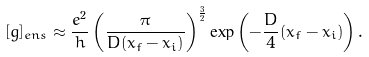<formula> <loc_0><loc_0><loc_500><loc_500>[ g ] _ { e n s } \approx \frac { e ^ { 2 } } { h } \left ( \frac { \pi } { D ( x _ { f } - x _ { i } ) } \right ) ^ { \frac { 3 } { 2 } } \exp \left ( - \frac { D } { 4 } ( x _ { f } - x _ { i } ) \right ) .</formula> 